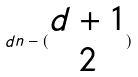Convert formula to latex. <formula><loc_0><loc_0><loc_500><loc_500>d n - ( \begin{matrix} d + 1 \\ 2 \end{matrix} )</formula> 